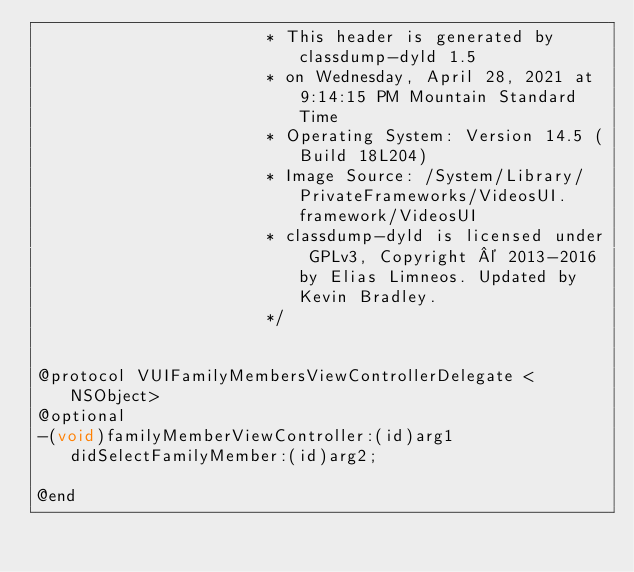Convert code to text. <code><loc_0><loc_0><loc_500><loc_500><_C_>                       * This header is generated by classdump-dyld 1.5
                       * on Wednesday, April 28, 2021 at 9:14:15 PM Mountain Standard Time
                       * Operating System: Version 14.5 (Build 18L204)
                       * Image Source: /System/Library/PrivateFrameworks/VideosUI.framework/VideosUI
                       * classdump-dyld is licensed under GPLv3, Copyright © 2013-2016 by Elias Limneos. Updated by Kevin Bradley.
                       */


@protocol VUIFamilyMembersViewControllerDelegate <NSObject>
@optional
-(void)familyMemberViewController:(id)arg1 didSelectFamilyMember:(id)arg2;

@end

</code> 